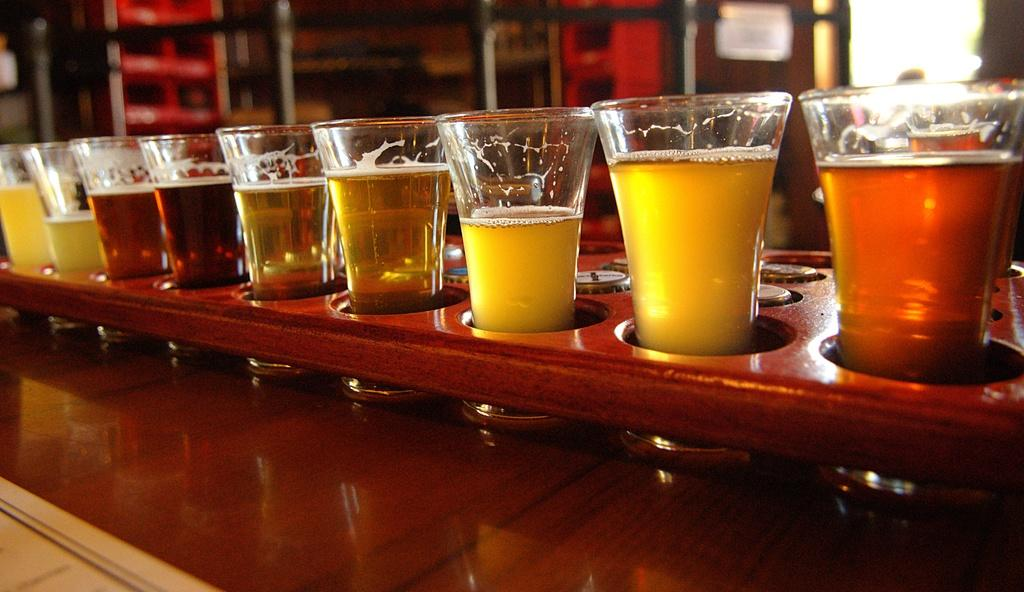What piece of furniture is present in the image? There is a table in the image. What can be found on the table? There are glasses of drink on the table. What type of farm animals can be seen grazing on the table in the image? There are no farm animals present in the image, and the table is not a grazing area for animals. 